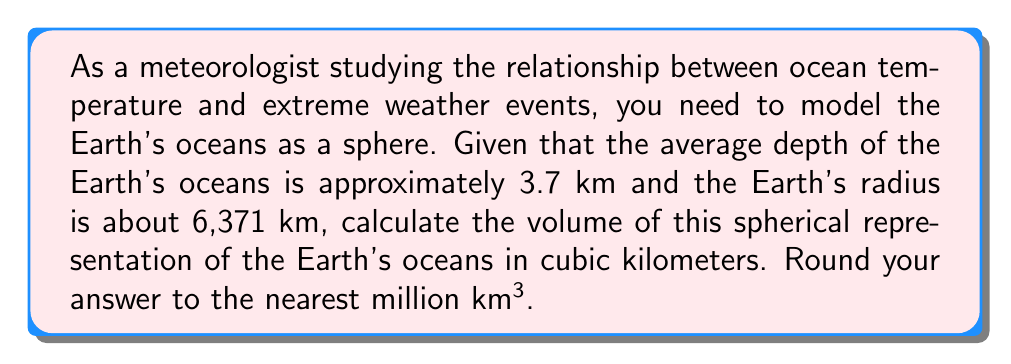Solve this math problem. To solve this problem, we need to follow these steps:

1) First, we need to calculate the radius of the sphere representing the oceans. This would be the Earth's radius minus the average depth of the oceans:

   $r = 6371 \text{ km} - 3.7 \text{ km} = 6367.3 \text{ km}$

2) The volume of a sphere is given by the formula:

   $$V = \frac{4}{3}\pi r^3$$

3) Let's substitute our radius into this formula:

   $$V = \frac{4}{3}\pi (6367.3)^3$$

4) Now we can calculate:

   $$\begin{align}
   V &= \frac{4}{3} \times \pi \times 6367.3^3 \\
   &\approx 1.33333 \times 3.14159 \times 257,908,707,514.7 \\
   &\approx 1,082,696,042,988 \text{ km}^3
   \end{align}$$

5) Rounding to the nearest million km³:

   $V \approx 1,082,696 \text{ million km}^3$

This represents the volume of a sphere with a radius equal to the Earth's radius minus the average ocean depth, which serves as a model for the volume of the Earth's oceans.
Answer: $1,082,696 \text{ million km}^3$ 